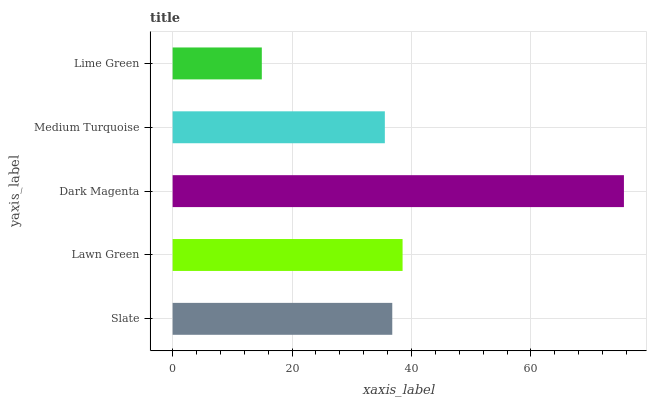Is Lime Green the minimum?
Answer yes or no. Yes. Is Dark Magenta the maximum?
Answer yes or no. Yes. Is Lawn Green the minimum?
Answer yes or no. No. Is Lawn Green the maximum?
Answer yes or no. No. Is Lawn Green greater than Slate?
Answer yes or no. Yes. Is Slate less than Lawn Green?
Answer yes or no. Yes. Is Slate greater than Lawn Green?
Answer yes or no. No. Is Lawn Green less than Slate?
Answer yes or no. No. Is Slate the high median?
Answer yes or no. Yes. Is Slate the low median?
Answer yes or no. Yes. Is Lime Green the high median?
Answer yes or no. No. Is Lawn Green the low median?
Answer yes or no. No. 